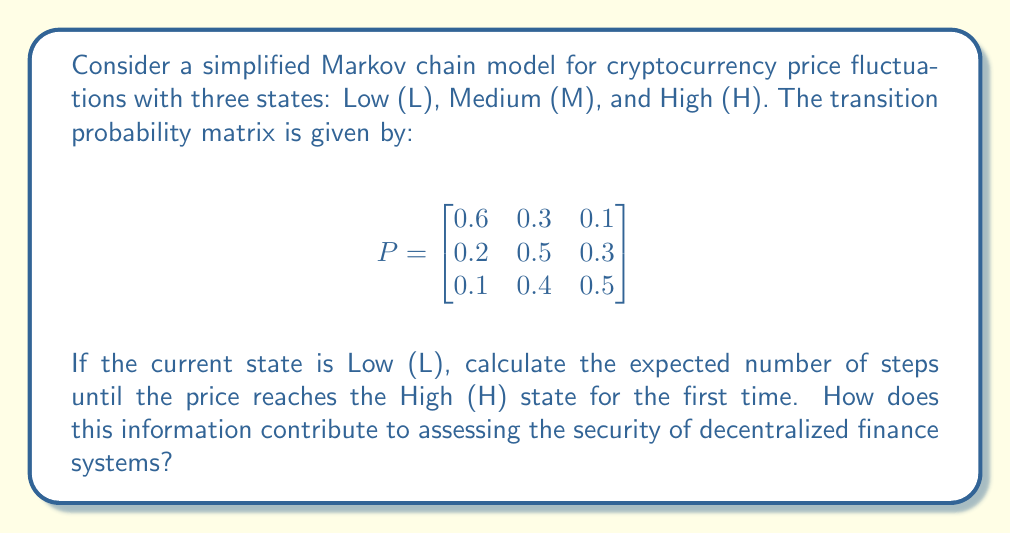What is the answer to this math problem? To solve this problem, we'll use the concept of first passage times in Markov chains. Let $m_{ij}$ denote the expected number of steps to reach state $j$ for the first time, starting from state $i$.

Step 1: Set up the system of equations for the expected first passage times:

$m_{LH} = 1 + 0.6m_{LH} + 0.3m_{MH}$
$m_{MH} = 1 + 0.2m_{LH} + 0.5m_{MH}$

Step 2: Simplify the equations:

$0.4m_{LH} - 0.3m_{MH} = 1$ (Equation 1)
$-0.2m_{LH} + 0.5m_{MH} = 1$ (Equation 2)

Step 3: Solve the system of equations using substitution or matrix methods:

Multiplying Equation 1 by 5 and Equation 2 by 2:

$2m_{LH} - 1.5m_{MH} = 5$
$-0.4m_{LH} + m_{MH} = 2$

Adding these equations:

$1.6m_{LH} - 0.5m_{MH} = 7$

Substituting this into Equation 1:

$0.4m_{LH} - 0.3(\frac{1.6m_{LH} - 7}{0.5}) = 1$

$0.4m_{LH} - 0.96m_{LH} + 4.2 = 1$

$-0.56m_{LH} = -3.2$

$m_{LH} = \frac{3.2}{0.56} = \frac{100}{17.5} \approx 5.71$

Step 4: Interpret the result:
The expected number of steps to reach the High state from the Low state is approximately 5.71 steps.

This information contributes to assessing the security of decentralized finance systems by:
1. Helping predict price volatility and potential risks.
2. Informing risk management strategies for DeFi protocols.
3. Assisting in the design of more robust smart contracts that can handle various price scenarios.
4. Providing insights for implementing circuit breakers or other security measures in decentralized exchanges.
Answer: 5.71 steps 